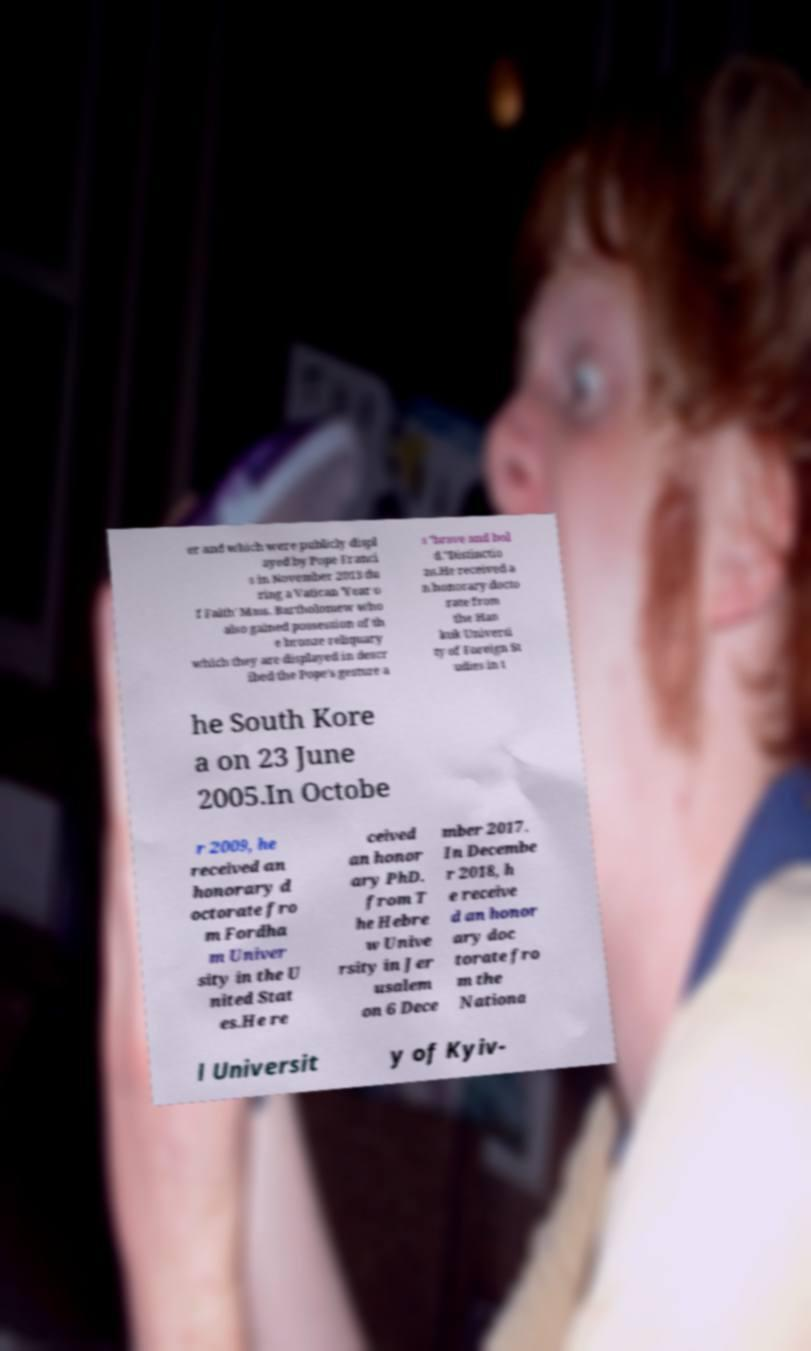Please read and relay the text visible in this image. What does it say? er and which were publicly displ ayed by Pope Franci s in November 2013 du ring a Vatican 'Year o f Faith' Mass. Bartholomew who also gained possession of th e bronze reliquary which they are displayed in descr ibed the Pope's gesture a s "brave and bol d."Distinctio ns.He received a n honorary docto rate from the Han kuk Universi ty of Foreign St udies in t he South Kore a on 23 June 2005.In Octobe r 2009, he received an honorary d octorate fro m Fordha m Univer sity in the U nited Stat es.He re ceived an honor ary PhD. from T he Hebre w Unive rsity in Jer usalem on 6 Dece mber 2017. In Decembe r 2018, h e receive d an honor ary doc torate fro m the Nationa l Universit y of Kyiv- 